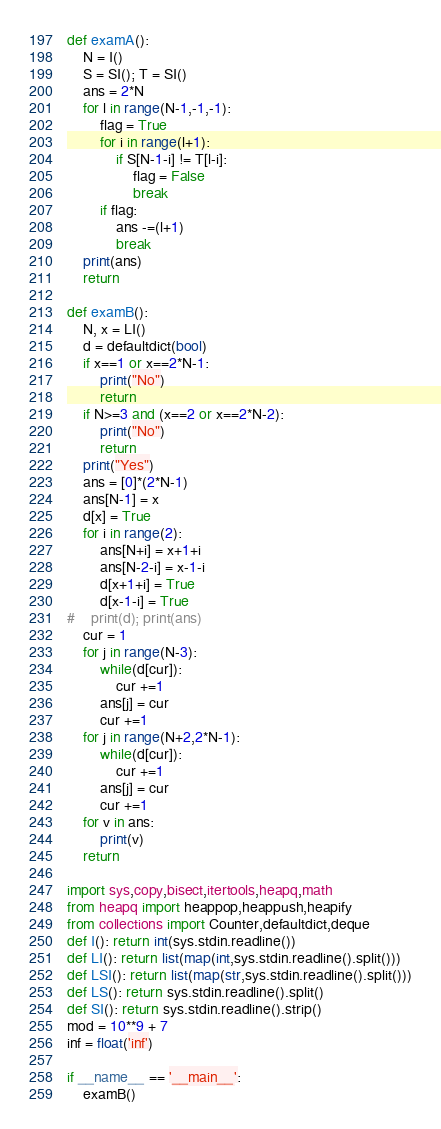Convert code to text. <code><loc_0><loc_0><loc_500><loc_500><_Python_>def examA():
    N = I()
    S = SI(); T = SI()
    ans = 2*N
    for l in range(N-1,-1,-1):
        flag = True
        for i in range(l+1):
            if S[N-1-i] != T[l-i]:
                flag = False
                break
        if flag:
            ans -=(l+1)
            break
    print(ans)
    return

def examB():
    N, x = LI()
    d = defaultdict(bool)
    if x==1 or x==2*N-1:
        print("No")
        return
    if N>=3 and (x==2 or x==2*N-2):
        print("No")
        return
    print("Yes")
    ans = [0]*(2*N-1)
    ans[N-1] = x
    d[x] = True
    for i in range(2):
        ans[N+i] = x+1+i
        ans[N-2-i] = x-1-i
        d[x+1+i] = True
        d[x-1-i] = True
#    print(d); print(ans)
    cur = 1
    for j in range(N-3):
        while(d[cur]):
            cur +=1
        ans[j] = cur
        cur +=1
    for j in range(N+2,2*N-1):
        while(d[cur]):
            cur +=1
        ans[j] = cur
        cur +=1
    for v in ans:
        print(v)
    return

import sys,copy,bisect,itertools,heapq,math
from heapq import heappop,heappush,heapify
from collections import Counter,defaultdict,deque
def I(): return int(sys.stdin.readline())
def LI(): return list(map(int,sys.stdin.readline().split()))
def LSI(): return list(map(str,sys.stdin.readline().split()))
def LS(): return sys.stdin.readline().split()
def SI(): return sys.stdin.readline().strip()
mod = 10**9 + 7
inf = float('inf')

if __name__ == '__main__':
    examB()
</code> 